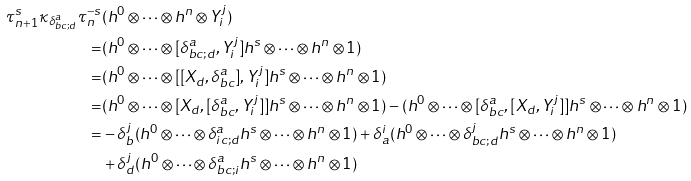Convert formula to latex. <formula><loc_0><loc_0><loc_500><loc_500>\tau _ { n + 1 } ^ { s } \kappa _ { \delta _ { b c ; d } ^ { a } } \tau _ { n } ^ { - s } & ( h ^ { 0 } \otimes \cdots \otimes h ^ { n } \otimes Y _ { i } ^ { j } ) \\ = & ( h ^ { 0 } \otimes \cdots \otimes [ \delta _ { b c ; d } ^ { a } , Y _ { i } ^ { j } ] h ^ { s } \otimes \cdots \otimes h ^ { n } \otimes 1 ) \\ = & ( h ^ { 0 } \otimes \cdots \otimes [ [ X _ { d } , \delta _ { b c } ^ { a } ] , Y _ { i } ^ { j } ] h ^ { s } \otimes \cdots \otimes h ^ { n } \otimes 1 ) \\ = & ( h ^ { 0 } \otimes \cdots \otimes [ X _ { d } , [ \delta _ { b c } ^ { a } , Y _ { i } ^ { j } ] ] h ^ { s } \otimes \cdots \otimes h ^ { n } \otimes 1 ) - ( h ^ { 0 } \otimes \cdots \otimes [ \delta _ { b c } ^ { a } , [ X _ { d } , Y _ { i } ^ { j } ] ] h ^ { s } \otimes \cdots \otimes h ^ { n } \otimes 1 ) \\ = & - \delta _ { b } ^ { j } ( h ^ { 0 } \otimes \cdots \otimes \delta _ { i c ; d } ^ { a } h ^ { s } \otimes \cdots \otimes h ^ { n } \otimes 1 ) + \delta _ { a } ^ { i } ( h ^ { 0 } \otimes \cdots \otimes \delta _ { b c ; d } ^ { j } h ^ { s } \otimes \cdots \otimes h ^ { n } \otimes 1 ) \\ & + \delta _ { d } ^ { j } ( h ^ { 0 } \otimes \cdots \otimes \delta _ { b c ; i } ^ { a } h ^ { s } \otimes \cdots \otimes h ^ { n } \otimes 1 )</formula> 